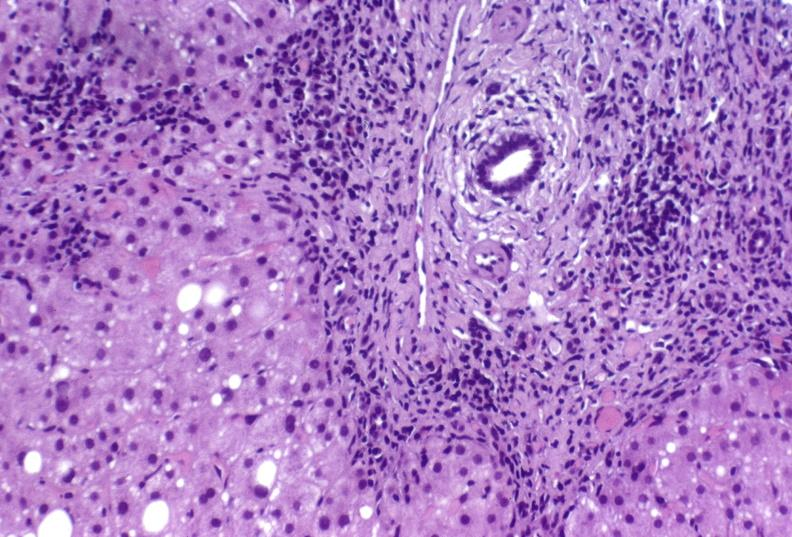what does this image show?
Answer the question using a single word or phrase. Hepatitis c virus 